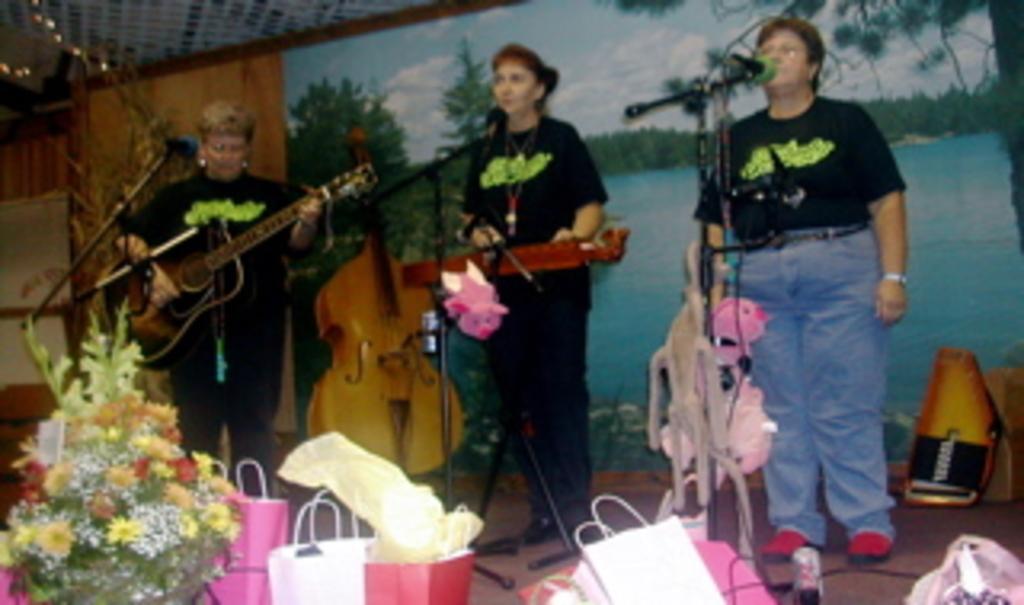Describe this image in one or two sentences. In this picture we can see three woman standing where one is holding guitar in her hand and playing it and other two are singing on mics and in front of them we can see bouquet, bag and at back of them we can see frame to wall, violin. 